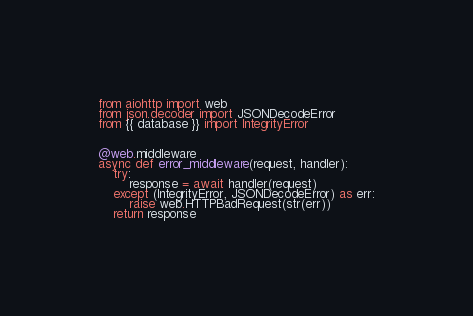Convert code to text. <code><loc_0><loc_0><loc_500><loc_500><_Python_>from aiohttp import web
from json.decoder import JSONDecodeError
from {{ database }} import IntegrityError


@web.middleware
async def error_middleware(request, handler):
    try:
        response = await handler(request)
    except (IntegrityError, JSONDecodeError) as err:
        raise web.HTTPBadRequest(str(err))
    return response
</code> 